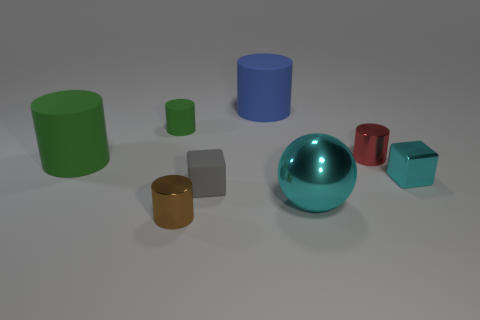How many shiny cylinders are there?
Your answer should be very brief. 2. Is the cylinder in front of the tiny cyan block made of the same material as the large green thing?
Offer a very short reply. No. Is there any other thing that is the same material as the big blue cylinder?
Keep it short and to the point. Yes. There is a large rubber cylinder on the right side of the brown metal cylinder that is to the left of the matte cube; how many tiny objects are to the left of it?
Provide a short and direct response. 3. How big is the blue matte cylinder?
Offer a terse response. Large. Is the shiny ball the same color as the tiny rubber cylinder?
Offer a very short reply. No. How big is the cyan ball that is in front of the gray matte cube?
Keep it short and to the point. Large. There is a big cylinder left of the gray rubber cube; is it the same color as the block that is to the left of the big blue matte thing?
Make the answer very short. No. How many other objects are there of the same shape as the small green rubber thing?
Ensure brevity in your answer.  4. Is the number of blue rubber cylinders on the right side of the tiny red cylinder the same as the number of green cylinders that are right of the small cyan metal thing?
Offer a very short reply. Yes. 